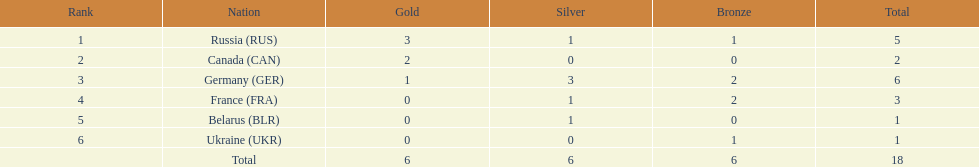Parse the table in full. {'header': ['Rank', 'Nation', 'Gold', 'Silver', 'Bronze', 'Total'], 'rows': [['1', 'Russia\xa0(RUS)', '3', '1', '1', '5'], ['2', 'Canada\xa0(CAN)', '2', '0', '0', '2'], ['3', 'Germany\xa0(GER)', '1', '3', '2', '6'], ['4', 'France\xa0(FRA)', '0', '1', '2', '3'], ['5', 'Belarus\xa0(BLR)', '0', '1', '0', '1'], ['6', 'Ukraine\xa0(UKR)', '0', '0', '1', '1'], ['', 'Total', '6', '6', '6', '18']]} Who had a larger total medal count, france or canada? France. 